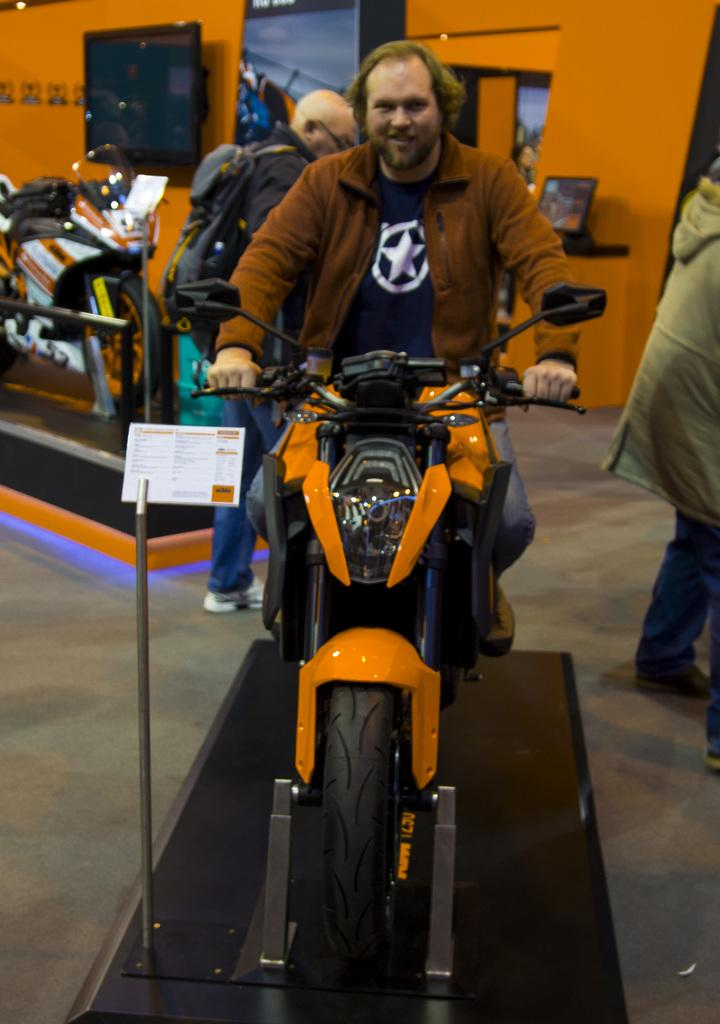What is the man in the image doing? The man is sitting on a motorbicycle in the image. Can you describe the other person in the image? There is another man wearing a backpack and standing in the image. What electronic devices are visible in the image? There is a laptop and a plasma TV in the image. What type of wheel is visible in the image? There is no wheel present in the image; the man is sitting on a motorbicycle, but the wheel is not visible. Can you describe the tub in the image? There is no tub present in the image. 